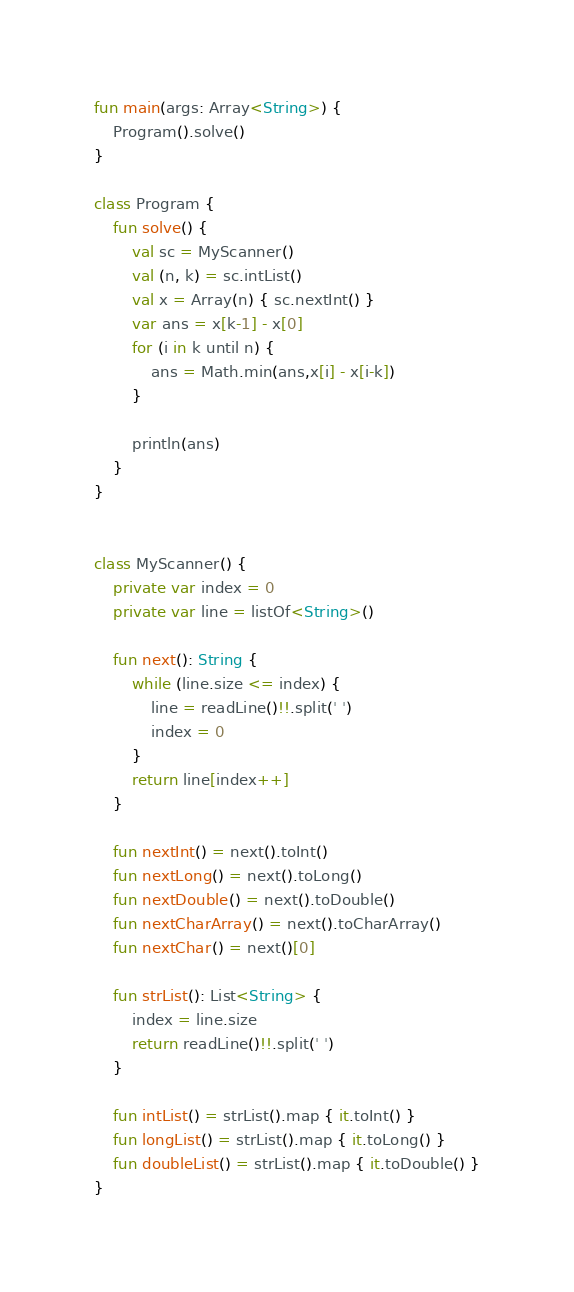Convert code to text. <code><loc_0><loc_0><loc_500><loc_500><_Kotlin_>fun main(args: Array<String>) {
    Program().solve()
}

class Program {
    fun solve() {
        val sc = MyScanner()
        val (n, k) = sc.intList()
        val x = Array(n) { sc.nextInt() }
        var ans = x[k-1] - x[0]
        for (i in k until n) {
            ans = Math.min(ans,x[i] - x[i-k])
        }

        println(ans)
    }
}


class MyScanner() {
    private var index = 0
    private var line = listOf<String>()

    fun next(): String {
        while (line.size <= index) {
            line = readLine()!!.split(' ')
            index = 0
        }
        return line[index++]
    }

    fun nextInt() = next().toInt()
    fun nextLong() = next().toLong()
    fun nextDouble() = next().toDouble()
    fun nextCharArray() = next().toCharArray()
    fun nextChar() = next()[0]

    fun strList(): List<String> {
        index = line.size
        return readLine()!!.split(' ')
    }

    fun intList() = strList().map { it.toInt() }
    fun longList() = strList().map { it.toLong() }
    fun doubleList() = strList().map { it.toDouble() }
}</code> 